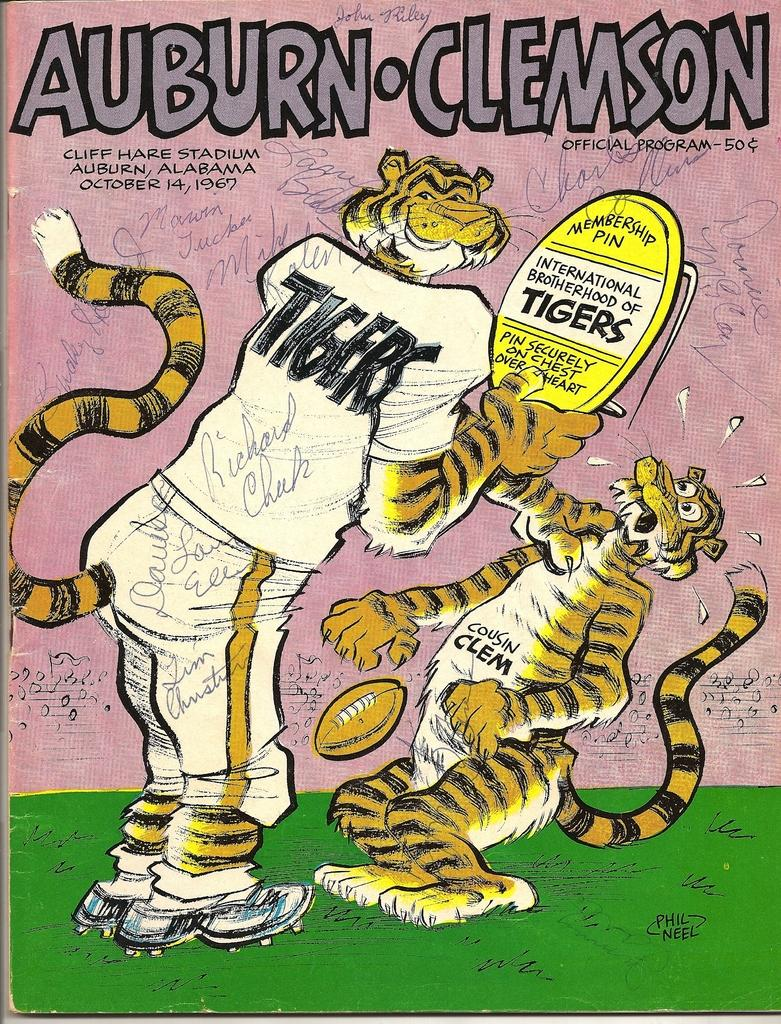What is the main object in the image? There is a pamphlet in the image. What can be found inside the pamphlet? The pamphlet contains two cartoon pictures. What colors are used for the cartoon pictures? The cartoon pictures are in yellow, white, and black colors. Is there any text on the pamphlet? Yes, there is text written on the pamphlet. What type of eggnog is being advertised on the pamphlet? There is no mention of eggnog on the pamphlet; it contains cartoon pictures and text. What property is being sold in the image? There is no property being sold in the image; it features a pamphlet with cartoon pictures and text. 